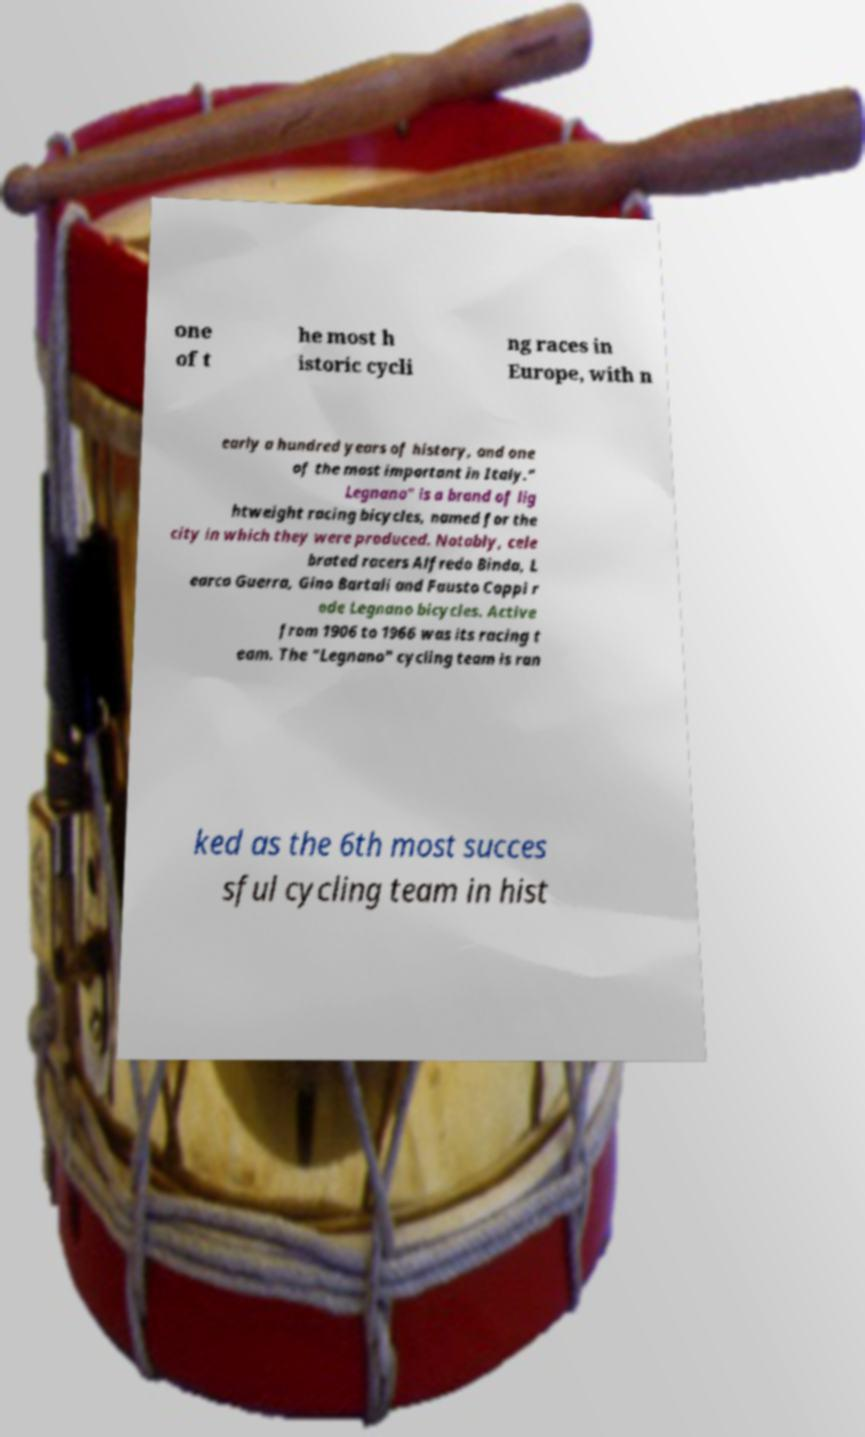What messages or text are displayed in this image? I need them in a readable, typed format. one of t he most h istoric cycli ng races in Europe, with n early a hundred years of history, and one of the most important in Italy." Legnano" is a brand of lig htweight racing bicycles, named for the city in which they were produced. Notably, cele brated racers Alfredo Binda, L earco Guerra, Gino Bartali and Fausto Coppi r ode Legnano bicycles. Active from 1906 to 1966 was its racing t eam. The "Legnano" cycling team is ran ked as the 6th most succes sful cycling team in hist 